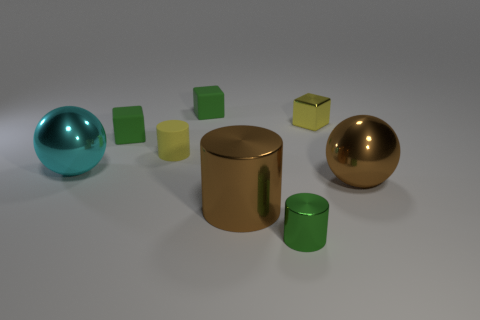Does the matte cylinder have the same color as the tiny metallic block?
Keep it short and to the point. Yes. Is there any other thing that is the same size as the metallic block?
Provide a short and direct response. Yes. There is a metallic object that is behind the big metallic object that is behind the brown shiny ball; what shape is it?
Provide a short and direct response. Cube. Is the number of big brown metallic balls less than the number of small metal things?
Provide a short and direct response. Yes. There is a shiny object that is both behind the big cylinder and on the left side of the small metallic cube; what is its size?
Offer a very short reply. Large. Is the size of the yellow shiny cube the same as the green metal cylinder?
Keep it short and to the point. Yes. Does the shiny thing that is to the left of the large shiny cylinder have the same color as the large metal cylinder?
Your response must be concise. No. What number of small objects are to the right of the matte cylinder?
Keep it short and to the point. 3. Is the number of green matte things greater than the number of cyan things?
Your answer should be compact. Yes. What is the shape of the object that is both on the left side of the yellow rubber object and right of the cyan thing?
Keep it short and to the point. Cube. 